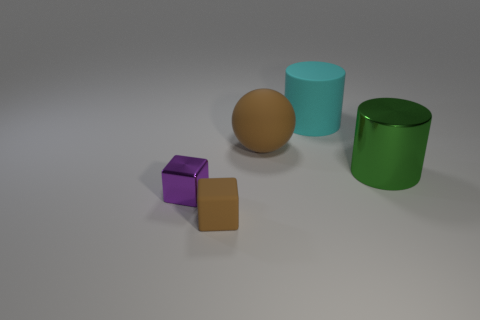What is the size of the cyan matte thing?
Give a very brief answer. Large. There is a big cylinder that is made of the same material as the small purple block; what color is it?
Offer a terse response. Green. How many rubber balls are the same size as the shiny block?
Provide a succinct answer. 0. Does the large thing that is to the left of the cyan object have the same material as the big cyan thing?
Make the answer very short. Yes. Are there fewer cyan matte cylinders that are behind the large brown object than brown matte spheres?
Give a very brief answer. No. What shape is the brown object to the right of the brown rubber cube?
Give a very brief answer. Sphere. What shape is the other matte object that is the same size as the purple thing?
Ensure brevity in your answer.  Cube. Are there any large green rubber things that have the same shape as the small brown matte object?
Ensure brevity in your answer.  No. Do the brown thing that is behind the green object and the big object that is on the right side of the large cyan matte cylinder have the same shape?
Your response must be concise. No. There is a green object that is the same size as the cyan cylinder; what is it made of?
Offer a very short reply. Metal. 